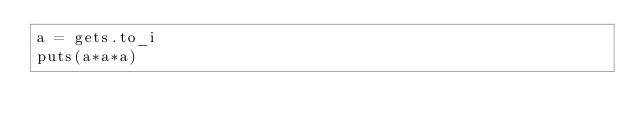<code> <loc_0><loc_0><loc_500><loc_500><_Ruby_>a = gets.to_i
puts(a*a*a)</code> 